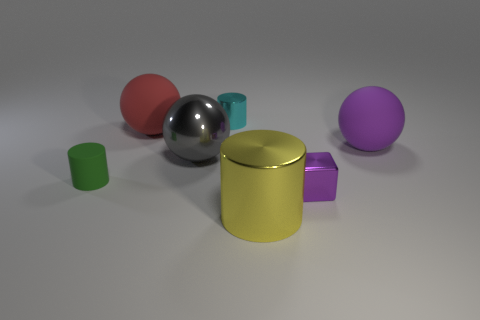Add 2 small cyan cylinders. How many objects exist? 9 Subtract all cubes. How many objects are left? 6 Add 7 small green objects. How many small green objects are left? 8 Add 3 large metal cylinders. How many large metal cylinders exist? 4 Subtract 0 green cubes. How many objects are left? 7 Subtract all big purple matte things. Subtract all green cylinders. How many objects are left? 5 